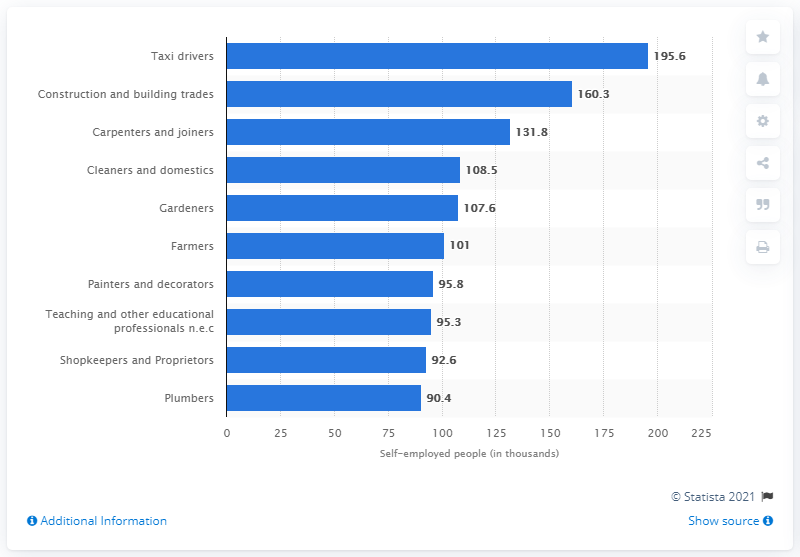Highlight a few significant elements in this photo. The most common occupation among self-employed individuals in the UK in 2018/19 was taxi drivers. 